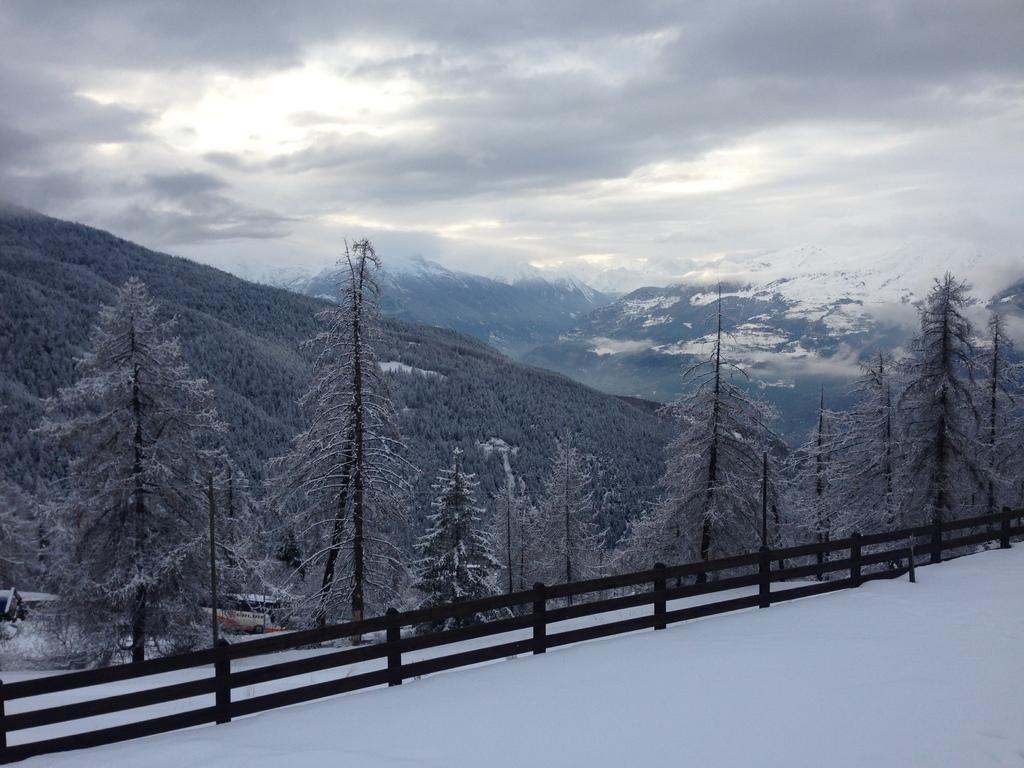Can you describe this image briefly? In the picture I can see the ground is covered with snow and there is a fence beside it and there are trees covered with snow beside the fence and there are mountains covered with snow in the background and the sky is cloudy. 